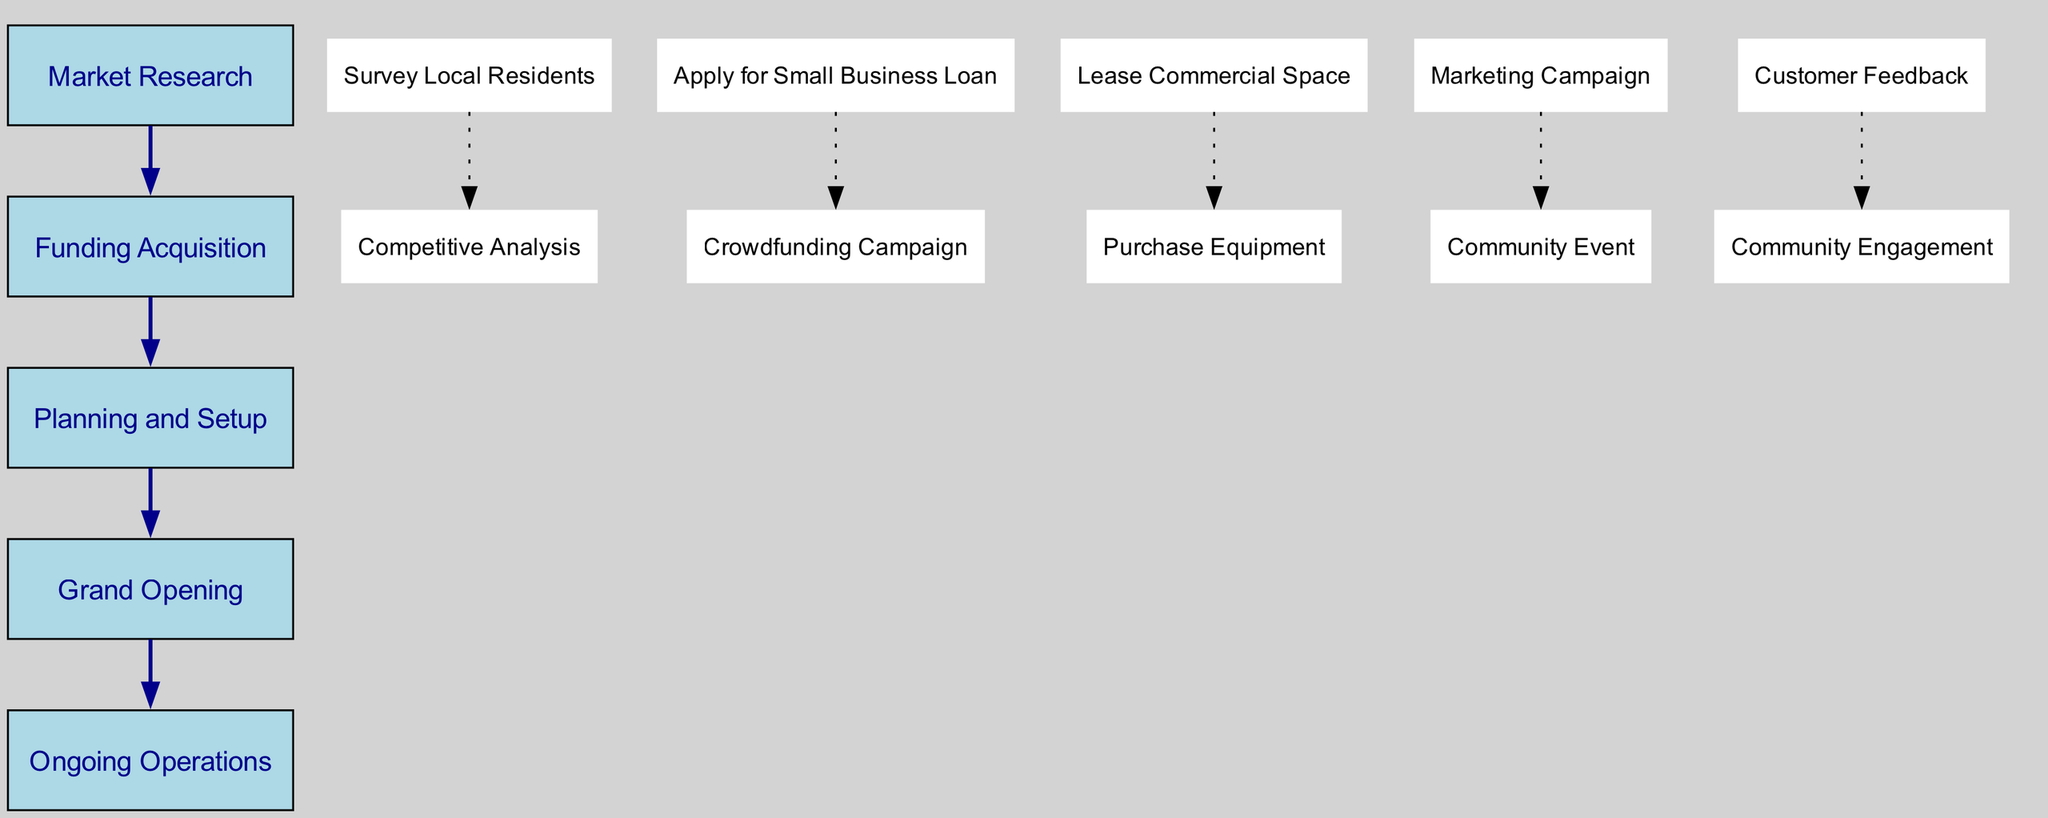What are the five main phases depicted in the diagram? The diagram outlines five main phases: Market Research, Funding Acquisition, Planning and Setup, Grand Opening, and Ongoing Operations.
Answer: Market Research, Funding Acquisition, Planning and Setup, Grand Opening, Ongoing Operations How many tasks are included in the Funding Acquisition phase? The Funding Acquisition phase includes two tasks: "Apply for Small Business Loan" and "Crowdfunding Campaign." Counting them gives a total of two tasks.
Answer: 2 Which phase comes immediately after the Grand Opening? After the Grand Opening phase, the next phase is Ongoing Operations, as shown by the directional arrow leading to it.
Answer: Ongoing Operations What type of campaign is mentioned in the Grand Opening phase? In the Grand Opening phase, the type of campaign mentioned is a "Marketing Campaign" used to promote the opening of the business.
Answer: Marketing Campaign What is the task associated with customer feedback in the Ongoing Operations phase? The task related to customer feedback in the Ongoing Operations phase is specifically named "Customer Feedback," which focuses on gathering and acting upon customer input.
Answer: Customer Feedback What is the relationship between the Planning and Setup phase and the Grand Opening phase? The Planning and Setup phase flows directly into the Grand Opening phase, indicated by an arrow connecting the two phases, signifying the sequential process followed by a new business.
Answer: Sequential Process Which two tasks are involved in the Market Research phase? The Market Research phase involves two specific tasks: "Survey Local Residents" and "Competitive Analysis." These tasks aim to gather community needs and competitive insights.
Answer: Survey Local Residents, Competitive Analysis How many total tasks are depicted across all phases? By counting the tasks within each phase (2 in Market Research, 2 in Funding Acquisition, 2 in Planning and Setup, 2 in Grand Opening, and 2 in Ongoing Operations), the total number reaches 10 tasks.
Answer: 10 